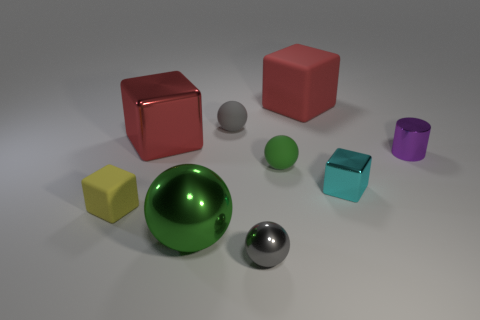Subtract all small metal blocks. How many blocks are left? 3 Subtract all gray blocks. How many green spheres are left? 2 Subtract all yellow blocks. How many blocks are left? 3 Subtract 1 blocks. How many blocks are left? 3 Add 1 small green matte cylinders. How many objects exist? 10 Subtract all blue blocks. Subtract all blue balls. How many blocks are left? 4 Subtract all cubes. How many objects are left? 5 Add 6 large red shiny objects. How many large red shiny objects are left? 7 Add 2 small yellow things. How many small yellow things exist? 3 Subtract 1 cyan blocks. How many objects are left? 8 